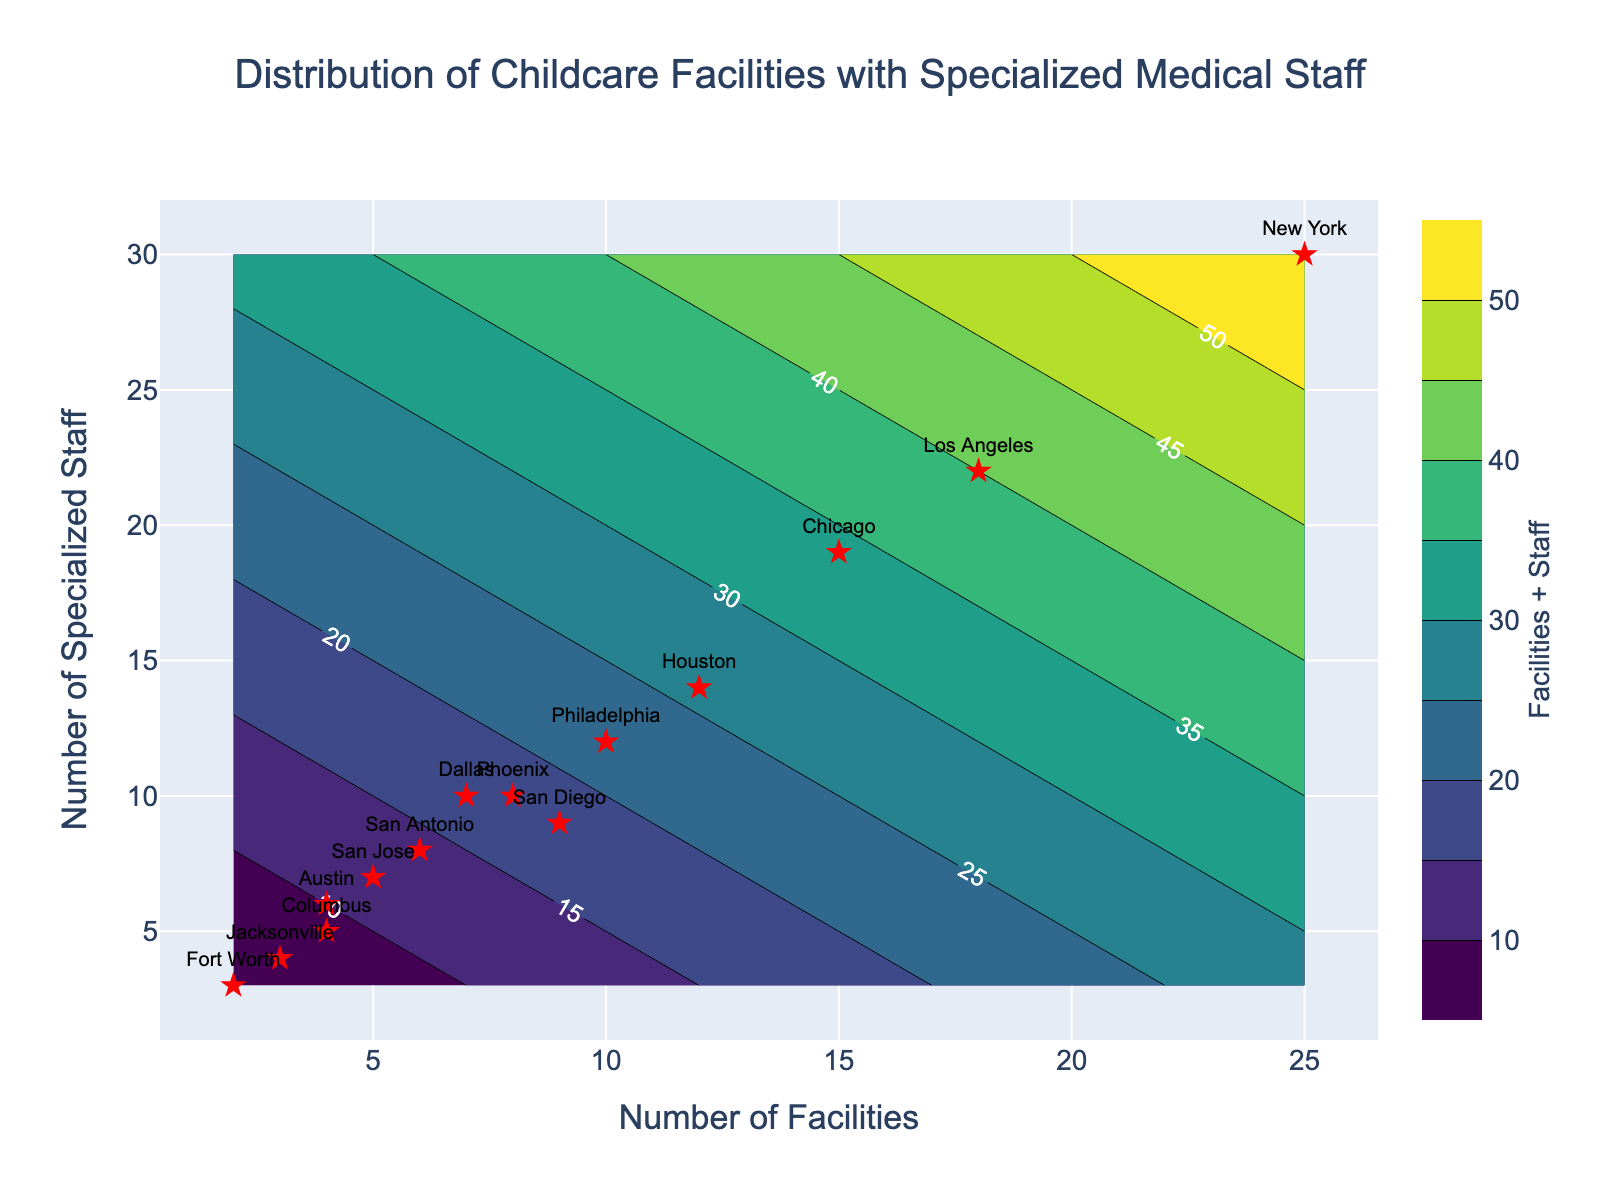How many childcare facilities have at least 10 specialized staff? From the contour plot, we count the number of cities with more than or equal to 10 specialized staff: New York, Los Angeles, Chicago, Philadelphia, and Dallas.
Answer: 5 Which city has the highest number of childcare facilities? Looking at the scatter points in the contour plot, the city with the farthest right placement on the x-axis represents the highest number of facilities, which is New York.
Answer: New York What is the combined number of facilities and specialized staff in Philadelphia? Philadelphia’s scatter point can be identified on the plot, where facilities are 10 and specialized staff are 12. Adding them gives 10 + 12.
Answer: 22 Which city has precisely equal numbers of childcare facilities and specialized staff? San Diego is the only city positioned at the coordinates (9, 9), indicating an equal count of facilities and staff.
Answer: San Diego Compare the numbers of specialized staff in Austin and Fort Worth. Which city has more specialized staff? Referring to the x-values associated with Austin (6) and Fort Worth (3), Austin has more specialized staff.
Answer: Austin Which cities have fewer than 5 childcare facilities? Observing the scatter points, San Jose (5), Austin (4), Jacksonville (3), Fort Worth (2), and Columbus (4) are identified as having fewer than 5 facilities.
Answer: San Jose, Austin, Jacksonville, Fort Worth, Columbus How many markers have labels in the figure? There are several scatter markers, each labeled with its respective city name which counts to a total of 14 labels.
Answer: 14 What feature does the color bar represent in the contour plot? The color bar on the right of the plot represents the combination of 'Facilities + Staff,' with a color gradient indicating intensity.
Answer: Facilities + Staff 